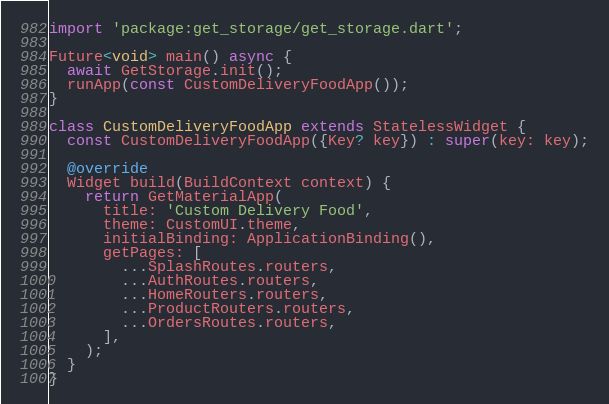Convert code to text. <code><loc_0><loc_0><loc_500><loc_500><_Dart_>import 'package:get_storage/get_storage.dart';

Future<void> main() async {
  await GetStorage.init();
  runApp(const CustomDeliveryFoodApp());
}

class CustomDeliveryFoodApp extends StatelessWidget {
  const CustomDeliveryFoodApp({Key? key}) : super(key: key);

  @override
  Widget build(BuildContext context) {
    return GetMaterialApp(
      title: 'Custom Delivery Food',
      theme: CustomUI.theme,
      initialBinding: ApplicationBinding(),
      getPages: [
        ...SplashRoutes.routers,
        ...AuthRoutes.routers,
        ...HomeRouters.routers,
        ...ProductRouters.routers,
        ...OrdersRoutes.routers,
      ],
    );
  }
}
</code> 